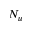<formula> <loc_0><loc_0><loc_500><loc_500>N _ { u }</formula> 